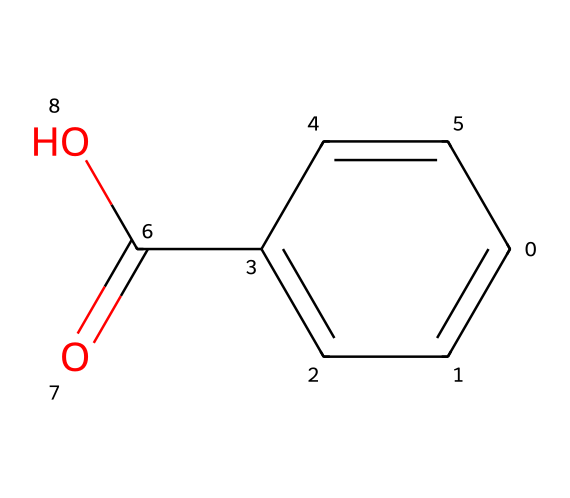How many carbon atoms are in benzoic acid? The SMILES representation indicates there are six carbon atoms in the aromatic ring (C1=CC=C(C=C1)) and one carbon in the carboxylic group (C(=O)O), totaling seven carbon atoms.
Answer: seven What is the molecular formula of benzoic acid? By analyzing the SMILES, count the atoms: 7 carbons (C), 6 hydrogens (H), and 2 oxygens (O), resulting in the molecular formula C7H6O2.
Answer: C7H6O2 Which functional group characterizes benzoic acid? The presence of the -COOH group in the SMILES (C(=O)O) identifies it as a carboxylic acid, which is a significant characteristic of benzoic acid.
Answer: carboxylic acid How many double bonds are present in benzoic acid? The SMILES shows four double bonds: one in the aromatic ring (C=C) and one in the carboxylic group (C=O), making a total of two.
Answer: two Why is benzoic acid effective as a preservative? The carboxylic acid functional group (-COOH) in benzoic acid contributes to its ability to inhibit microbial growth by lowering pH and disrupting microbial metabolism, making it effective as a food preservative.
Answer: inhibits microbial growth What type of compound is benzoic acid categorized as? Based on its structure and function, specifically due to the presence of the carboxylic acid group, benzoic acid is categorized as an aromatic carboxylic acid.
Answer: aromatic carboxylic acid What is the significance of the aromatic ring in benzoic acid? The aromatic ring provides stability and contributes to the overall properties of the compound, including its preservation characteristics in food products through its low pH impact.
Answer: stability and preservation 